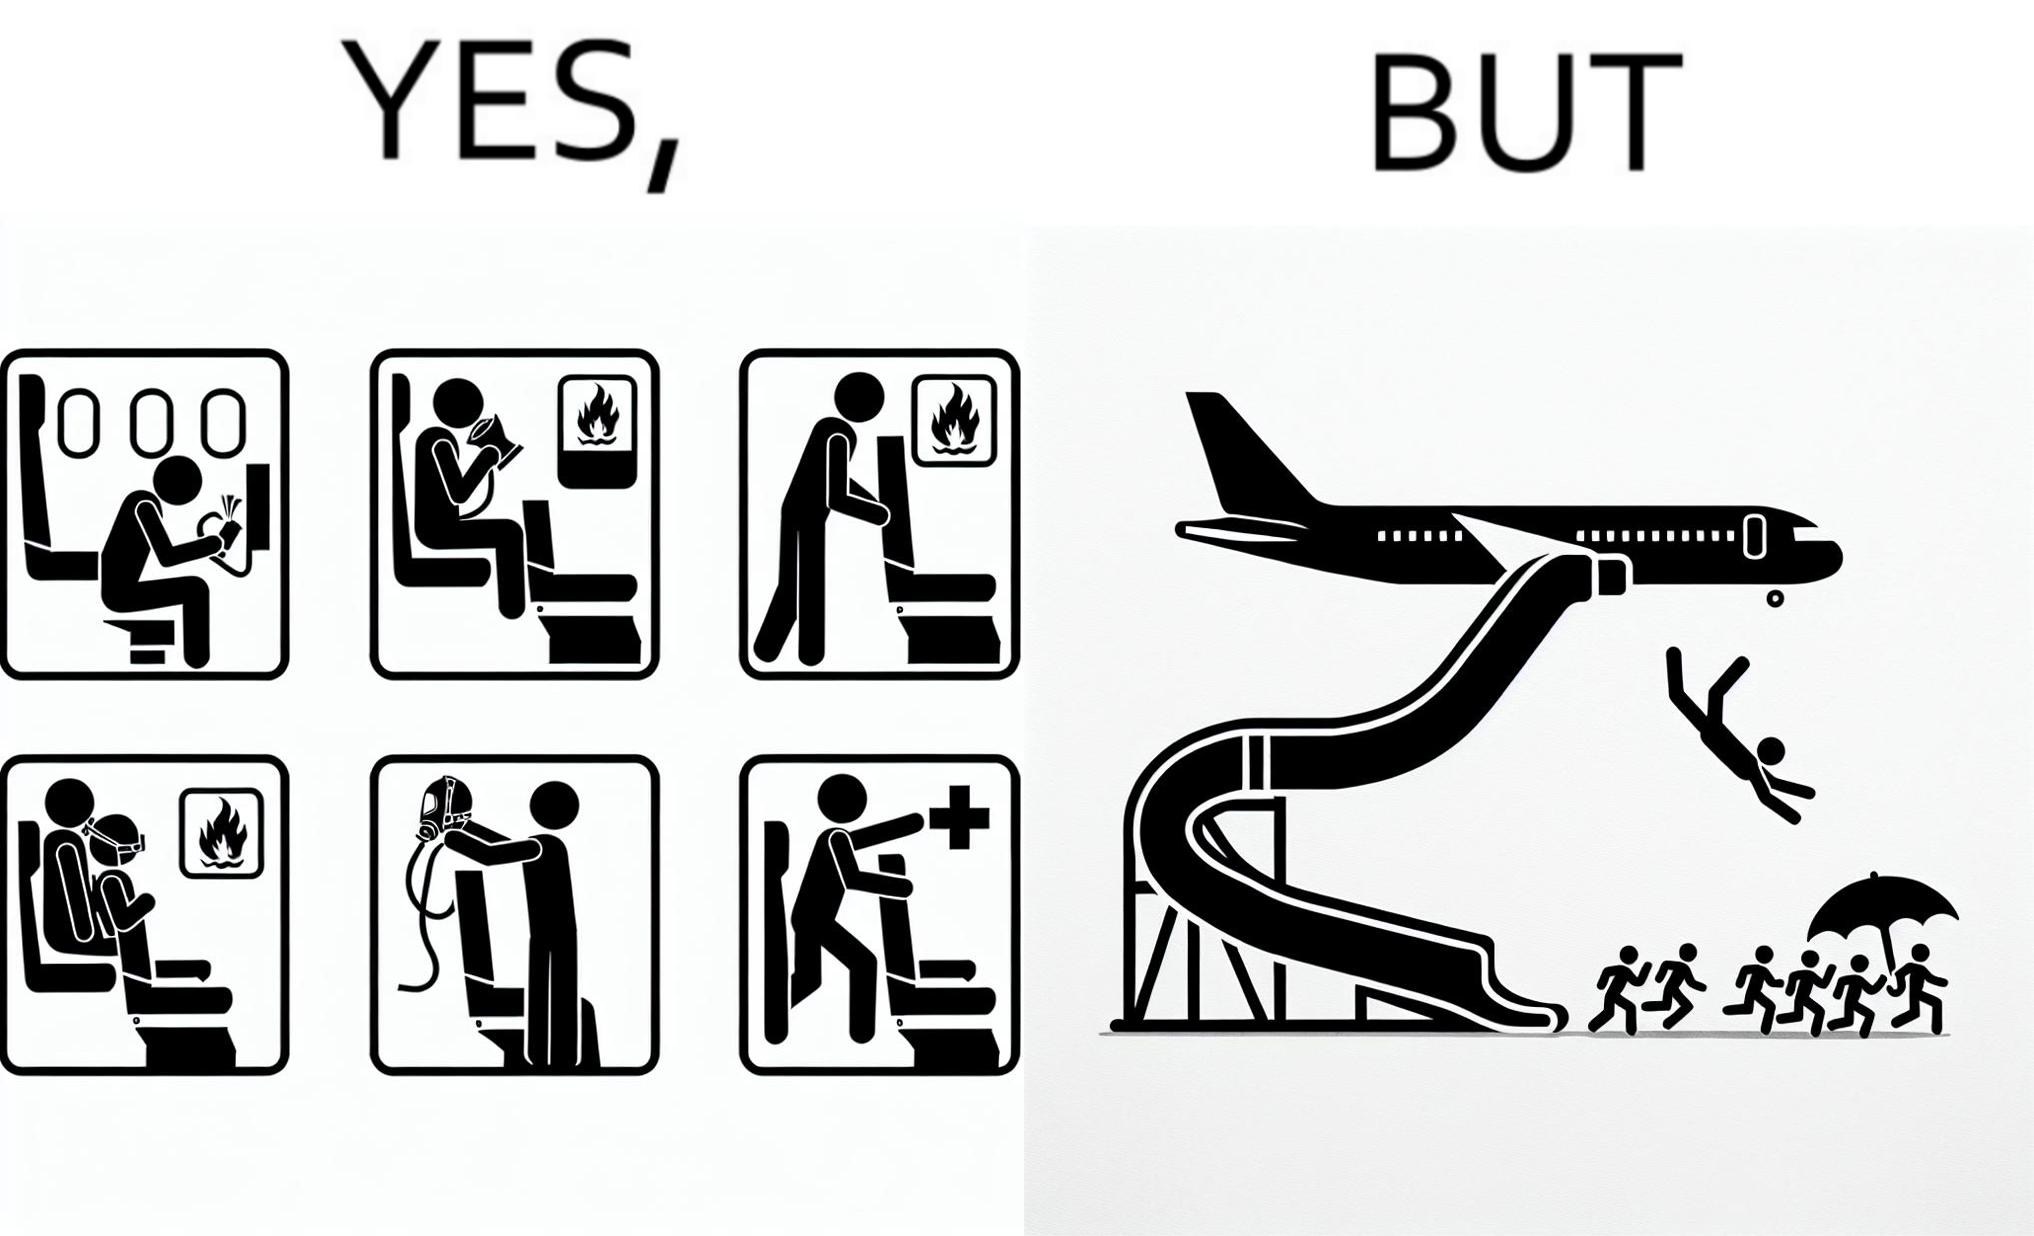Describe what you see in this image. These images are funny since it shows how we are taught emergency procedures to follow in case of an accident while in an airplane but how none of them work if the plane is still in air 